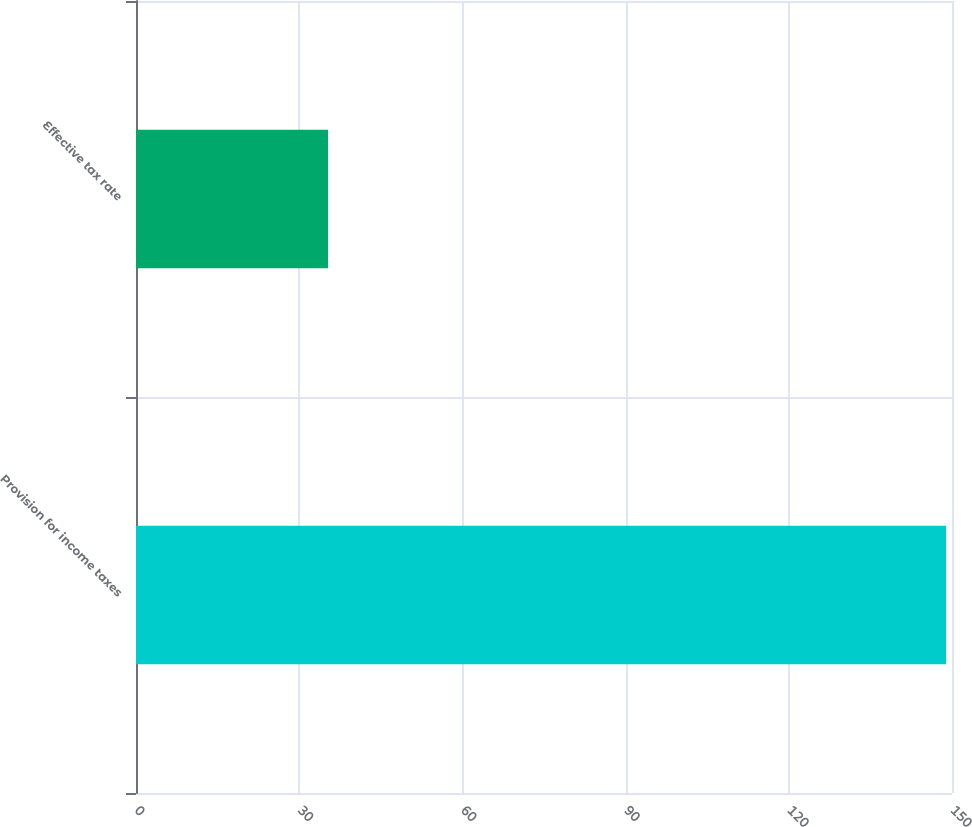<chart> <loc_0><loc_0><loc_500><loc_500><bar_chart><fcel>Provision for income taxes<fcel>Effective tax rate<nl><fcel>148.9<fcel>35.3<nl></chart> 